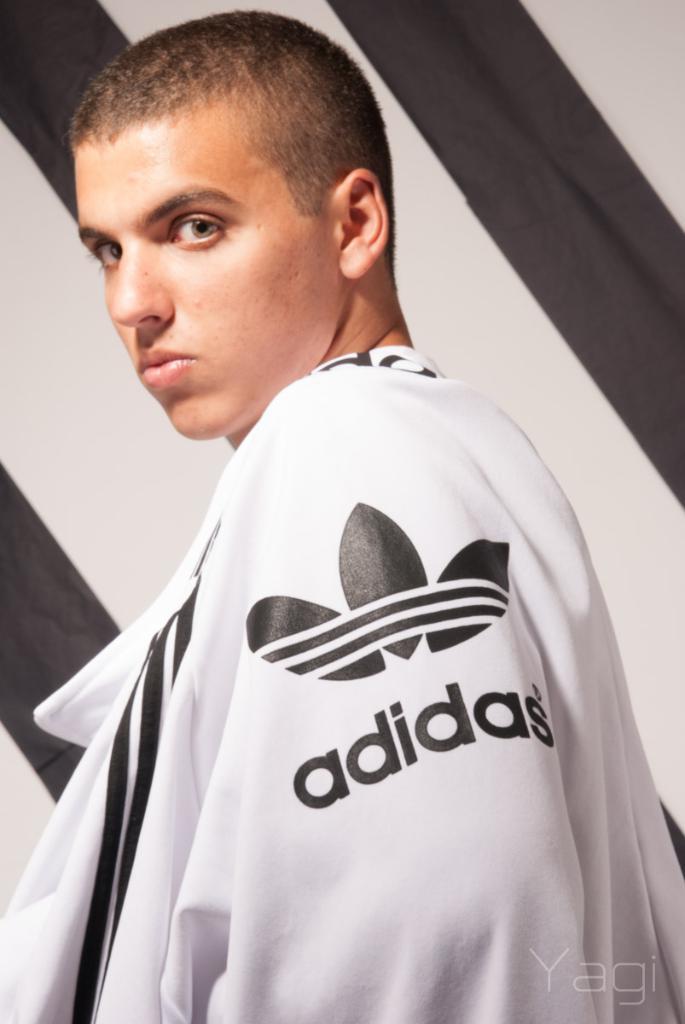What brand is his jacket?
Provide a short and direct response. Adidas. What letter case is the word on the jacket?
Provide a succinct answer. Lower. 